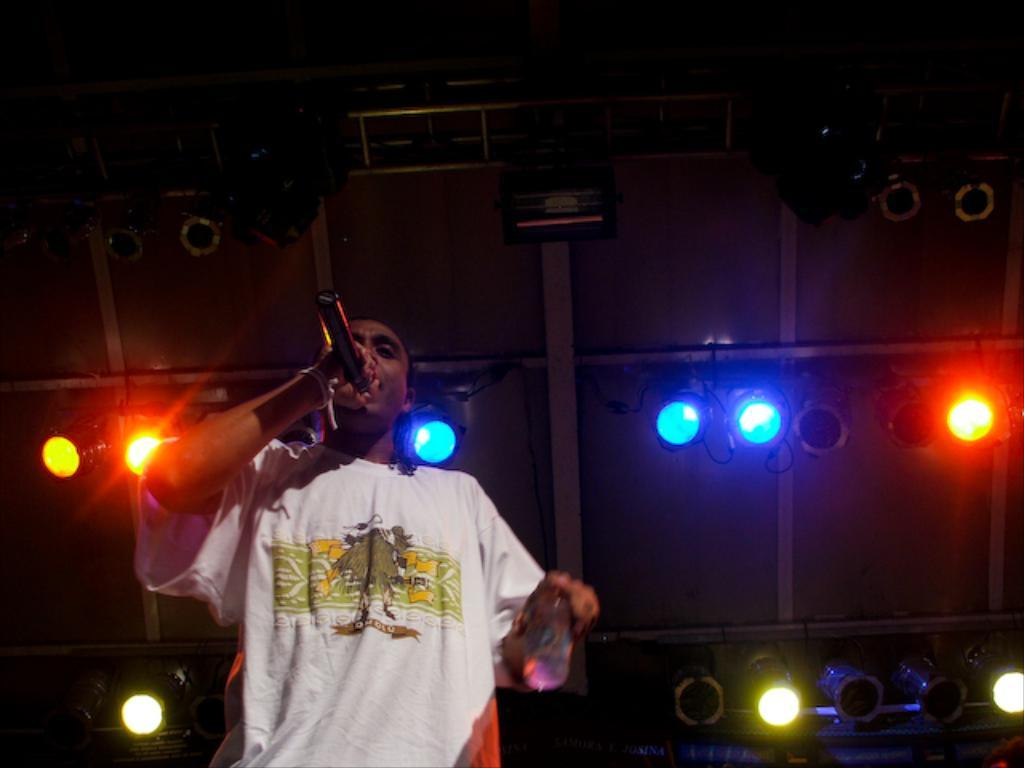What is the main subject of the image? There is a person in the image. What is the person wearing? The person is wearing a white T-shirt. What is the person holding in the image? The person is holding a mic. What is the person doing in the image? The person is singing. How is the background of the image described? The background of the image is dark. What can be seen in the background of the image besides the dark background? Show lights are present in the background of the image. What type of pencil is being used to draw the person in the image? There is no pencil present in the image, as it is a photograph of a person singing. What type of celery can be seen in the person's hand while they are singing? There is no celery present in the image; the person is holding a mic while singing. 